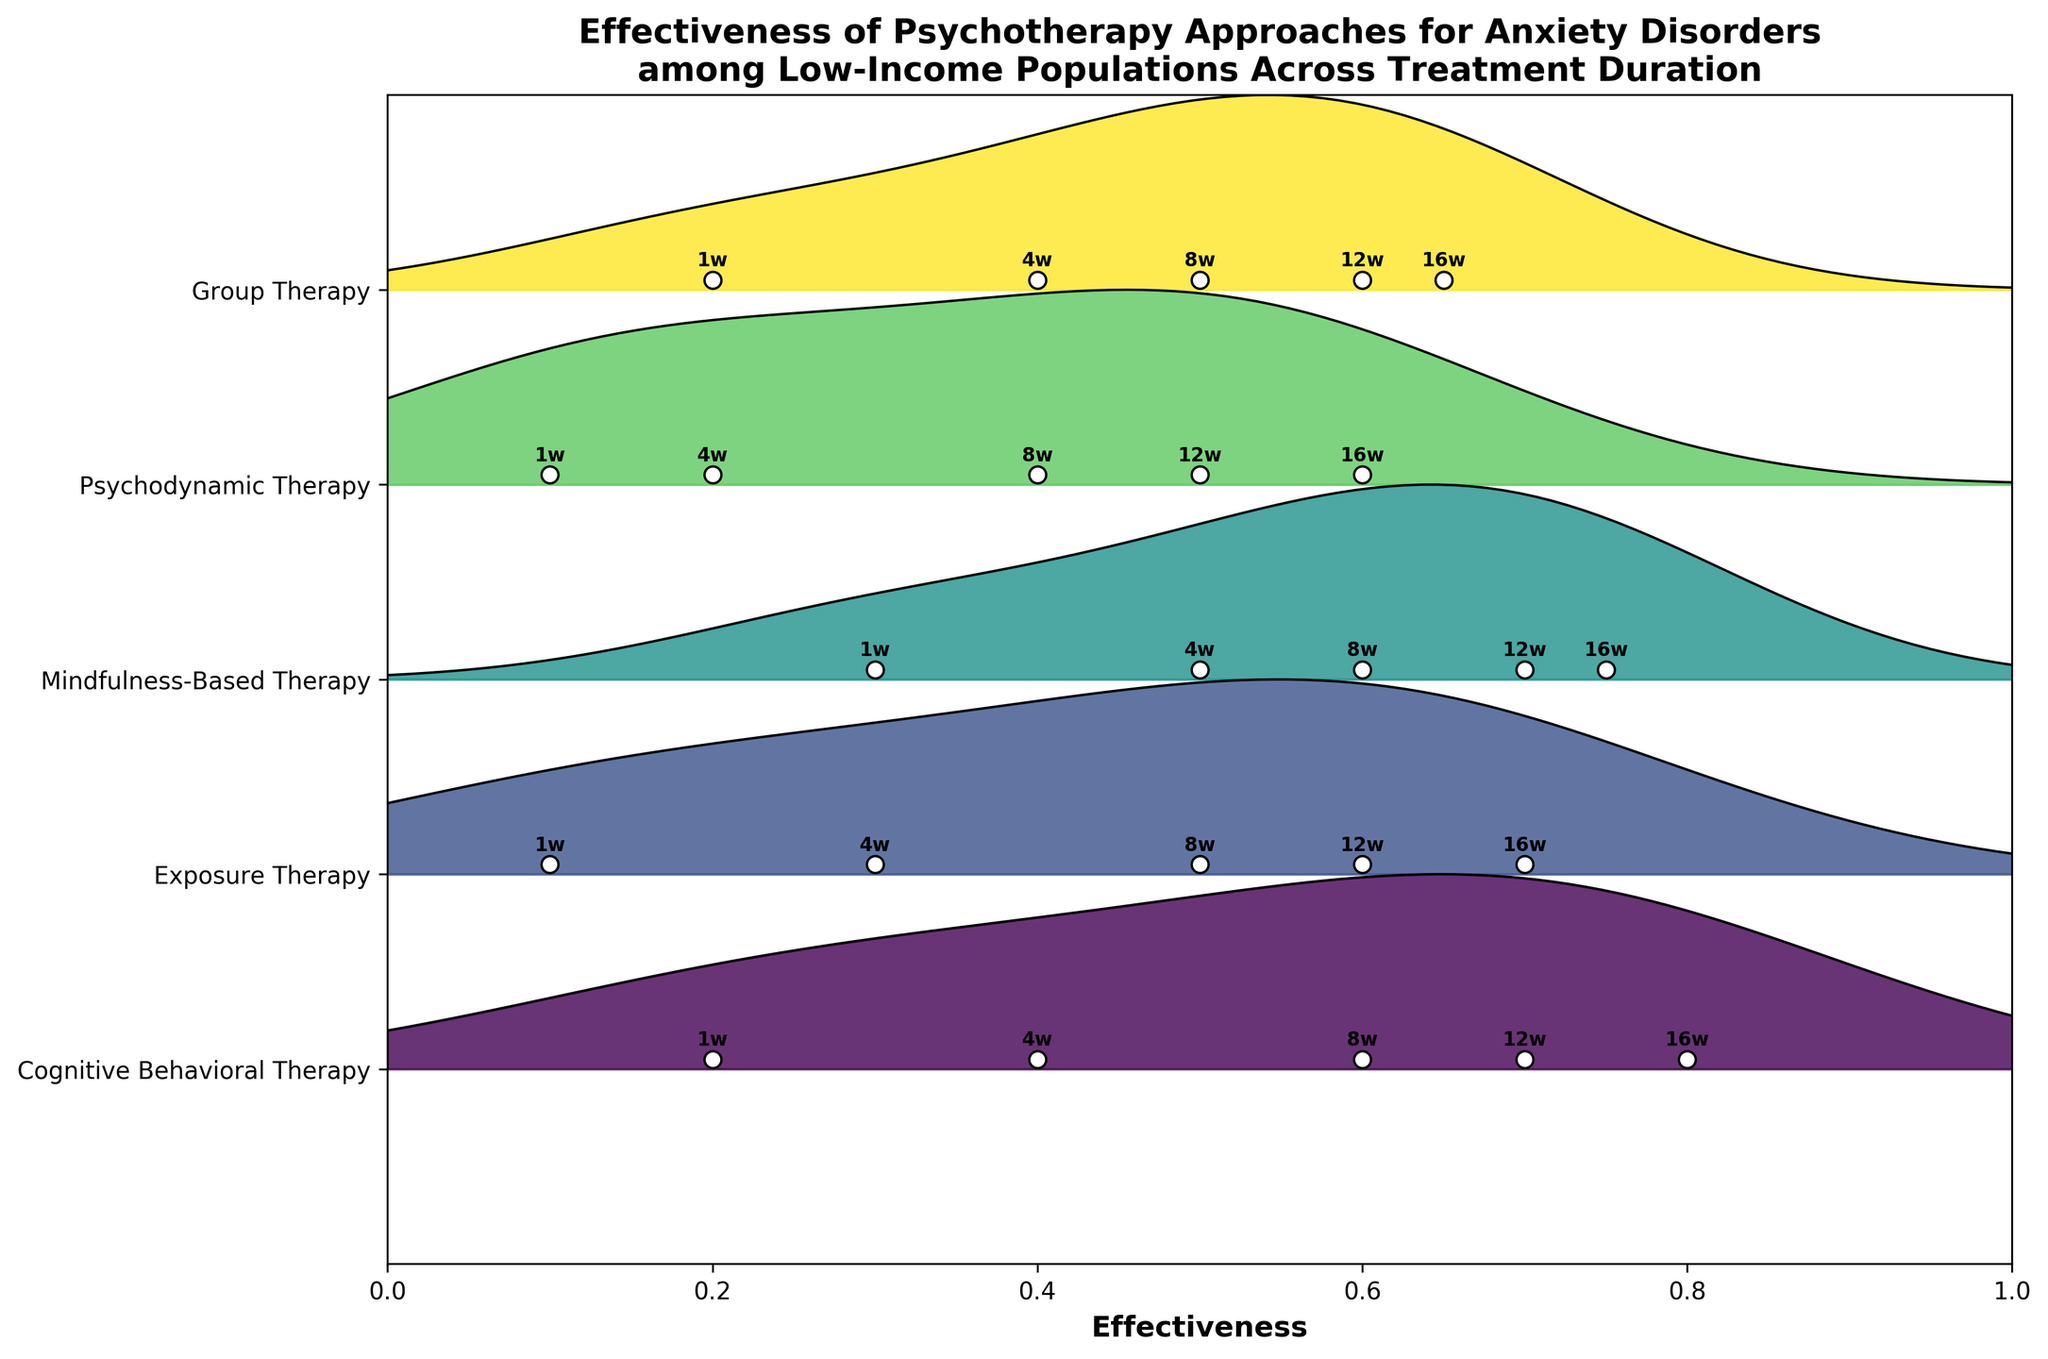Which psychotherapy approach shows the highest effectiveness at week 16? By comparing the effectiveness values at week 16 for all approaches, we see that Cognitive Behavioral Therapy has the highest effectiveness with a value of 0.8.
Answer: Cognitive Behavioral Therapy How does the effectiveness of Mindfulness-Based Therapy change from week 1 to week 16? Evaluating the effectiveness values for Mindfulness-Based Therapy, we see it starts at 0.3 in week 1 and increases to 0.75 in week 16.
Answer: Increases from 0.3 to 0.75 Which psychotherapy approach has the lowest initial effectiveness? By comparing the effectiveness values at week 1, Exposure Therapy and Psychodynamic Therapy both have the lowest effectiveness values at 0.1.
Answer: Exposure Therapy and Psychodynamic Therapy What is the average effectiveness of Group Therapy across all weeks? Summing the effectiveness values of Group Therapy (0.2, 0.4, 0.5, 0.6, 0.65) and dividing by the number of weeks (5), we get (0.2 + 0.4 + 0.5 + 0.6 + 0.65) / 5 = 2.35 / 5 = 0.47.
Answer: 0.47 Which therapy shows a faster initial improvement, Cognitive Behavioral Therapy or Exposure Therapy? Comparing the initial changes from week 1 to week 4, Cognitive Behavioral Therapy goes from 0.2 to 0.4 (an increase of 0.2), while Exposure Therapy goes from 0.1 to 0.3 (an increase of 0.2). Thus, both show the same rate of initial improvement.
Answer: Both equal How many different psychotherapy approaches are compared in the figure? By observing the y-axis labels, five different psychotherapy approaches are listed: Cognitive Behavioral Therapy, Exposure Therapy, Mindfulness-Based Therapy, Psychodynamic Therapy, and Group Therapy.
Answer: Five Is the effectiveness of Psychodynamic Therapy ever higher than 0.6? Cross-referencing the effectiveness values for Psychodynamic Therapy at all weeks, we see that the highest effectiveness value reached is 0.6 and never exceeds it.
Answer: No Which week shows the most similar effectiveness across all approaches? Comparing the effectiveness values across all approaches week by week, week 8 shows the most similarity with values ranging from 0.4 to 0.6.
Answer: Week 8 